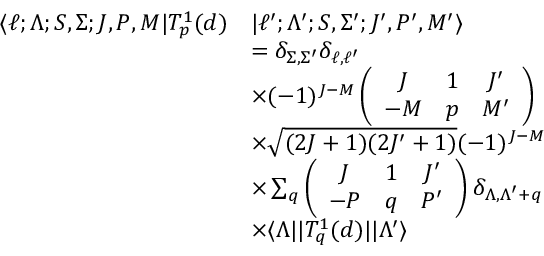Convert formula to latex. <formula><loc_0><loc_0><loc_500><loc_500>\begin{array} { r l } { \langle \ell ; \Lambda ; S , \Sigma ; J , P , M | T _ { p } ^ { 1 } ( d ) } & { | \ell ^ { \prime } ; \Lambda ^ { \prime } ; S , \Sigma ^ { \prime } ; J ^ { \prime } , P ^ { \prime } , M ^ { \prime } \rangle } \\ & { = \delta _ { \Sigma , \Sigma ^ { \prime } } \delta _ { \ell , \ell ^ { \prime } } } \\ & { \times ( - 1 ) ^ { J - M } \left ( \begin{array} { c c c } { J } & { 1 } & { J ^ { \prime } } \\ { - M } & { p } & { M ^ { \prime } } \end{array} \right ) } \\ & { \times \sqrt { ( 2 J + 1 ) ( 2 J ^ { \prime } + 1 ) } ( - 1 ) ^ { J - M } } \\ & { \times \sum _ { q } \left ( \begin{array} { c c c } { J } & { 1 } & { J ^ { \prime } } \\ { - P } & { q } & { P ^ { \prime } } \end{array} \right ) \delta _ { \Lambda , \Lambda ^ { \prime } + q } } \\ & { \times \langle \Lambda | | T _ { q } ^ { 1 } ( d ) | | \Lambda ^ { \prime } \rangle } \end{array}</formula> 